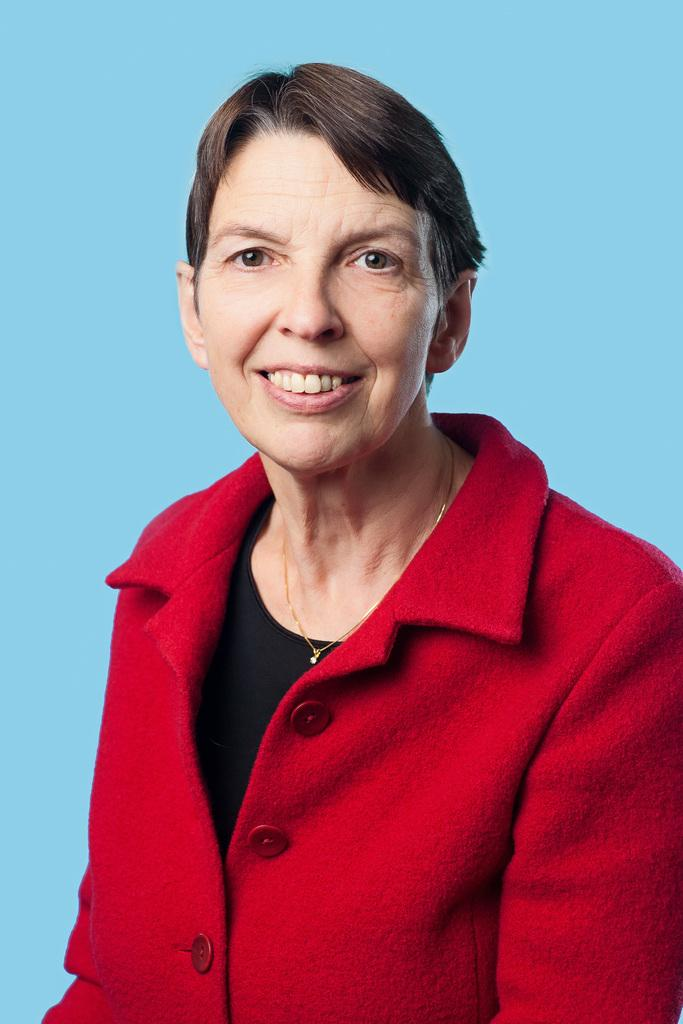Who is present in the image? There is a woman in the image. What is the woman wearing? The woman is wearing a red coat. What color is the background of the image? The background of the image is blue. How many frogs can be seen hopping in the image? There are no frogs present in the image. Can you provide an example of a similar image with a different background color? The provided facts do not include any other images, so it is not possible to provide an example of a similar image with a different background color. 